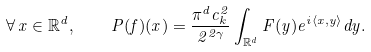Convert formula to latex. <formula><loc_0><loc_0><loc_500><loc_500>\forall \, x \in \mathbb { R } ^ { d } , \quad P ( f ) ( x ) = \frac { \pi ^ { d } c _ { k } ^ { 2 } } { 2 ^ { 2 \gamma } } \int _ { \mathbb { R } ^ { d } } F ( y ) e ^ { i \langle x , y \rangle } d y .</formula> 